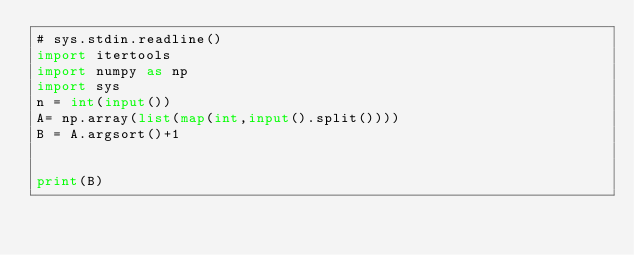<code> <loc_0><loc_0><loc_500><loc_500><_Python_># sys.stdin.readline()
import itertools
import numpy as np
import sys
n = int(input())
A= np.array(list(map(int,input().split())))
B = A.argsort()+1


print(B)
</code> 